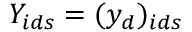<formula> <loc_0><loc_0><loc_500><loc_500>Y _ { i d s } = ( y _ { d } ) _ { i d s }</formula> 